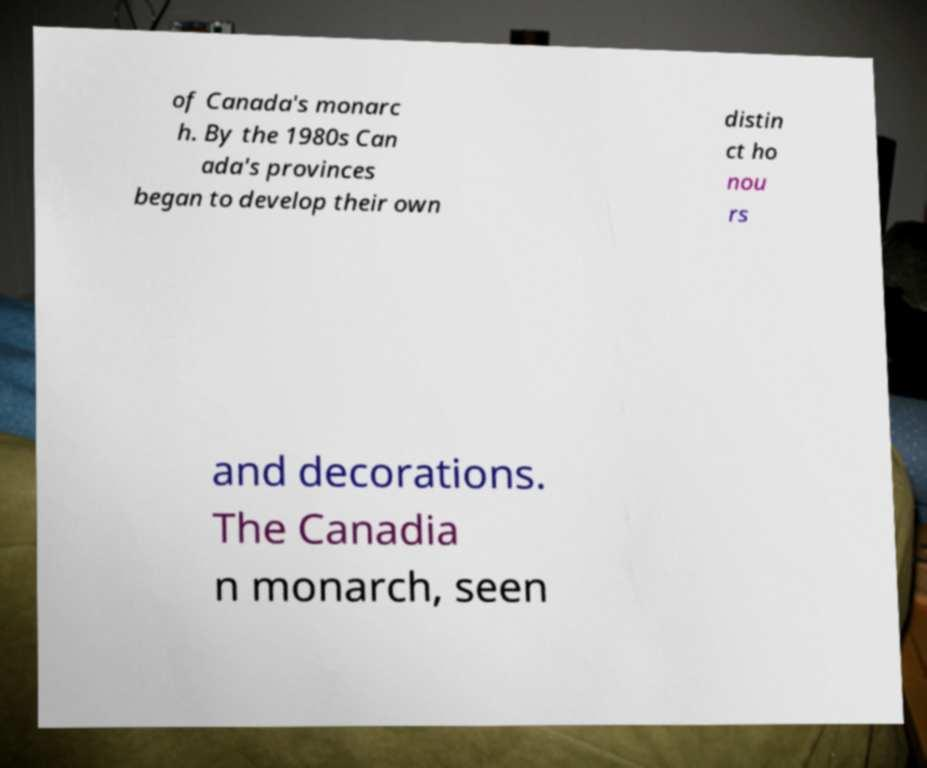There's text embedded in this image that I need extracted. Can you transcribe it verbatim? of Canada's monarc h. By the 1980s Can ada's provinces began to develop their own distin ct ho nou rs and decorations. The Canadia n monarch, seen 